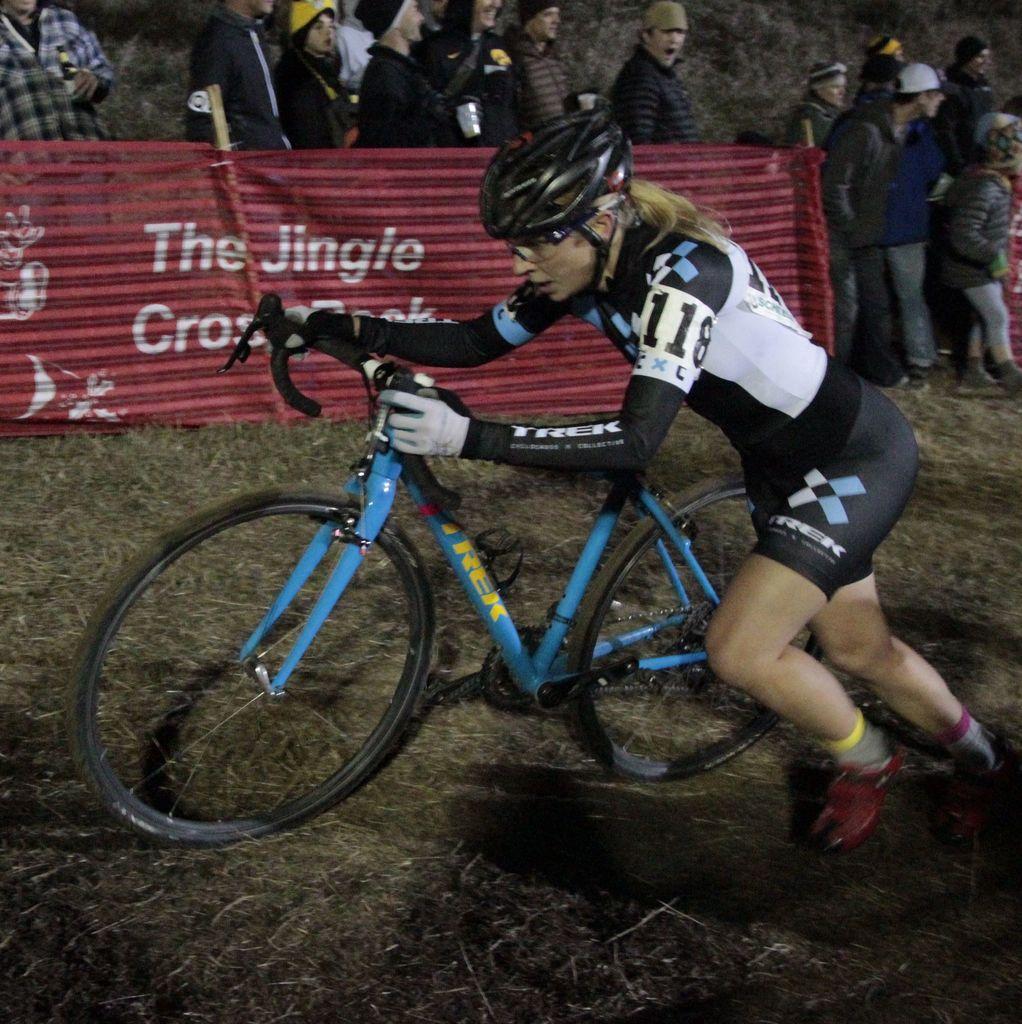Please provide a concise description of this image. This image is taken outdoors. At the bottom of the image there is a ground with grass on it. In the background a few people are standing on the ground and there is a banner with text on it. In the middle of the image a woman is running on the ground and she is holding a bicycle. 